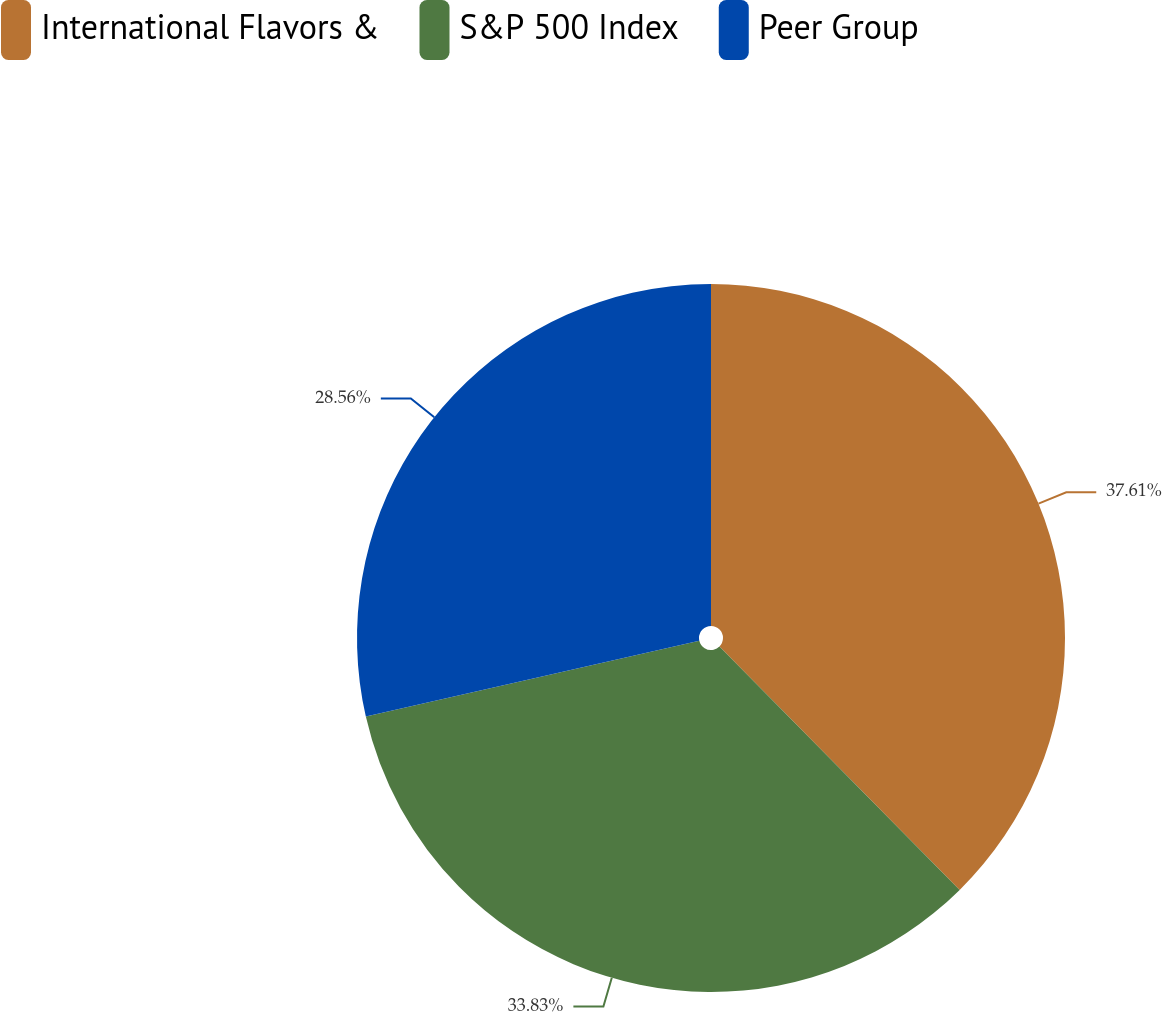Convert chart to OTSL. <chart><loc_0><loc_0><loc_500><loc_500><pie_chart><fcel>International Flavors &<fcel>S&P 500 Index<fcel>Peer Group<nl><fcel>37.6%<fcel>33.83%<fcel>28.56%<nl></chart> 